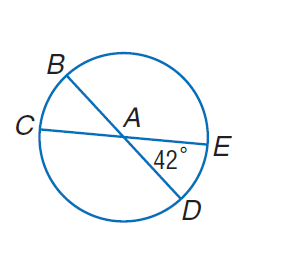Answer the mathemtical geometry problem and directly provide the correct option letter.
Question: In \odot A, m \angle E A D = 42. Find m \widehat C B E.
Choices: A: 90 B: 180 C: 270 D: 360 B 